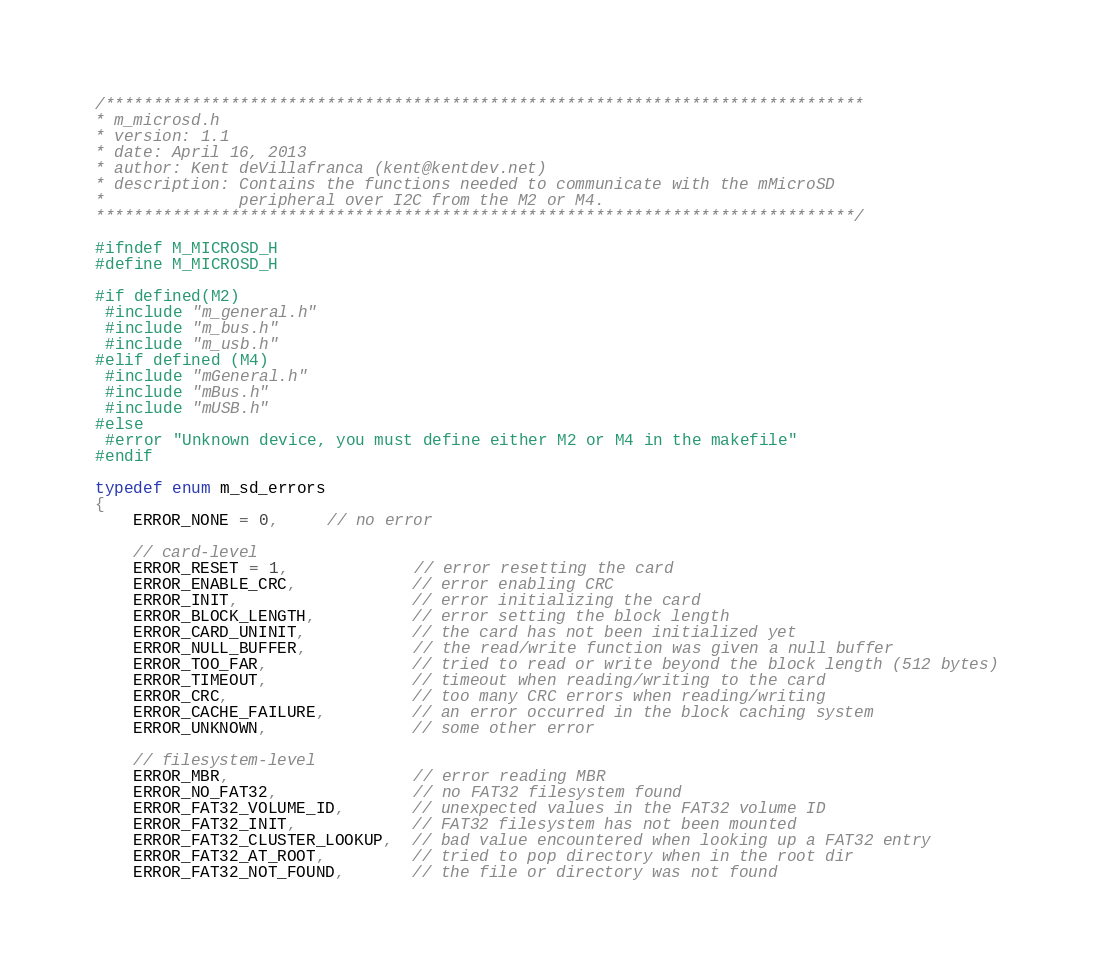<code> <loc_0><loc_0><loc_500><loc_500><_C_>/*******************************************************************************
* m_microsd.h
* version: 1.1
* date: April 16, 2013
* author: Kent deVillafranca (kent@kentdev.net)
* description: Contains the functions needed to communicate with the mMicroSD
*              peripheral over I2C from the M2 or M4.
*******************************************************************************/

#ifndef M_MICROSD_H
#define M_MICROSD_H

#if defined(M2)
 #include "m_general.h"
 #include "m_bus.h"
 #include "m_usb.h"
#elif defined (M4)
 #include "mGeneral.h"
 #include "mBus.h"
 #include "mUSB.h"
#else
 #error "Unknown device, you must define either M2 or M4 in the makefile"
#endif

typedef enum m_sd_errors
{
    ERROR_NONE = 0,     // no error
    
    // card-level
    ERROR_RESET = 1,             // error resetting the card
    ERROR_ENABLE_CRC,            // error enabling CRC
    ERROR_INIT,                  // error initializing the card
    ERROR_BLOCK_LENGTH,          // error setting the block length
    ERROR_CARD_UNINIT,           // the card has not been initialized yet
    ERROR_NULL_BUFFER,           // the read/write function was given a null buffer
    ERROR_TOO_FAR,               // tried to read or write beyond the block length (512 bytes)
    ERROR_TIMEOUT,               // timeout when reading/writing to the card
    ERROR_CRC,                   // too many CRC errors when reading/writing
    ERROR_CACHE_FAILURE,         // an error occurred in the block caching system
    ERROR_UNKNOWN,               // some other error
    
    // filesystem-level
    ERROR_MBR,                   // error reading MBR
    ERROR_NO_FAT32,              // no FAT32 filesystem found
    ERROR_FAT32_VOLUME_ID,       // unexpected values in the FAT32 volume ID
    ERROR_FAT32_INIT,            // FAT32 filesystem has not been mounted
    ERROR_FAT32_CLUSTER_LOOKUP,  // bad value encountered when looking up a FAT32 entry
    ERROR_FAT32_AT_ROOT,         // tried to pop directory when in the root dir
    ERROR_FAT32_NOT_FOUND,       // the file or directory was not found</code> 